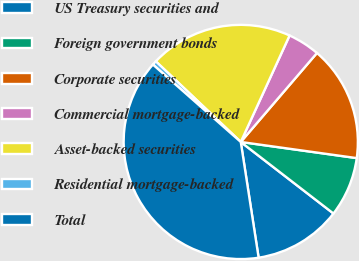Convert chart to OTSL. <chart><loc_0><loc_0><loc_500><loc_500><pie_chart><fcel>US Treasury securities and<fcel>Foreign government bonds<fcel>Corporate securities<fcel>Commercial mortgage-backed<fcel>Asset-backed securities<fcel>Residential mortgage-backed<fcel>Total<nl><fcel>12.1%<fcel>8.26%<fcel>15.93%<fcel>4.43%<fcel>19.76%<fcel>0.59%<fcel>38.93%<nl></chart> 